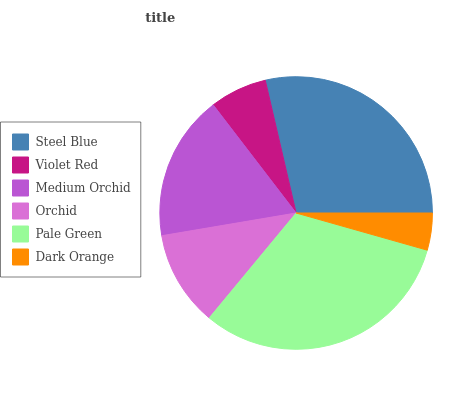Is Dark Orange the minimum?
Answer yes or no. Yes. Is Pale Green the maximum?
Answer yes or no. Yes. Is Violet Red the minimum?
Answer yes or no. No. Is Violet Red the maximum?
Answer yes or no. No. Is Steel Blue greater than Violet Red?
Answer yes or no. Yes. Is Violet Red less than Steel Blue?
Answer yes or no. Yes. Is Violet Red greater than Steel Blue?
Answer yes or no. No. Is Steel Blue less than Violet Red?
Answer yes or no. No. Is Medium Orchid the high median?
Answer yes or no. Yes. Is Orchid the low median?
Answer yes or no. Yes. Is Orchid the high median?
Answer yes or no. No. Is Medium Orchid the low median?
Answer yes or no. No. 